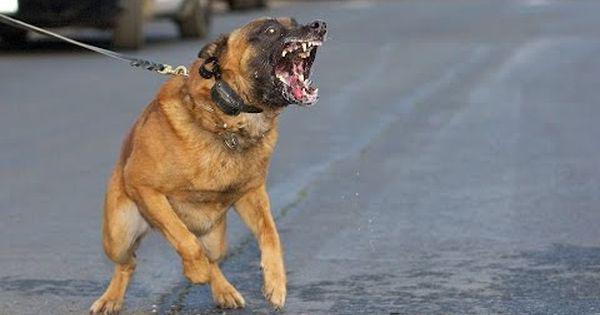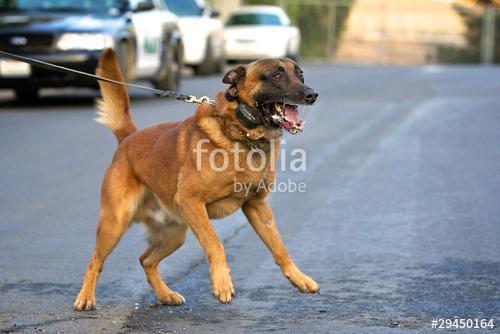The first image is the image on the left, the second image is the image on the right. For the images shown, is this caption "One dog stands and looks directly towards camera." true? Answer yes or no. No. 